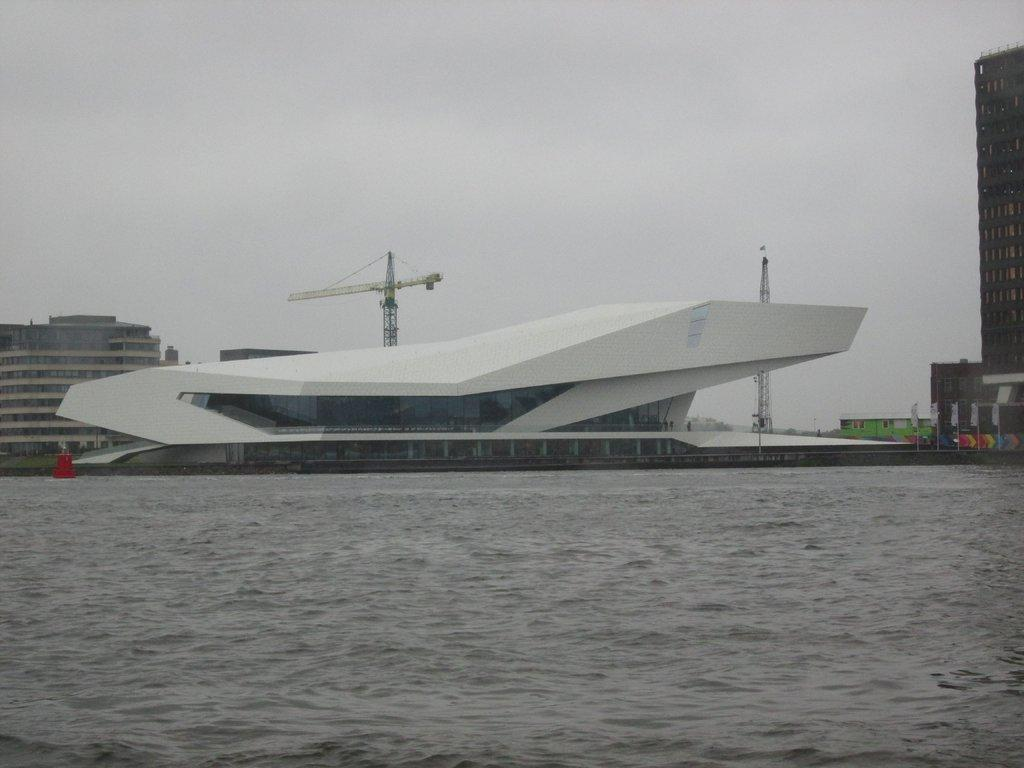What type of structures can be seen in the image? There are buildings in the image. What construction equipment is present in the image? There are cranes in the image. What decorative or symbolic objects are visible in the image? There are flags in the image. What is the weather like in the background of the image? The sky is cloudy in the background of the image. What natural element is visible at the bottom of the image? There is water visible at the bottom of the image. What type of wall can be seen in the image? There is no wall present in the image. How does the tramp interact with the water in the image? There is no tramp present in the image; it does not interact with the water. 